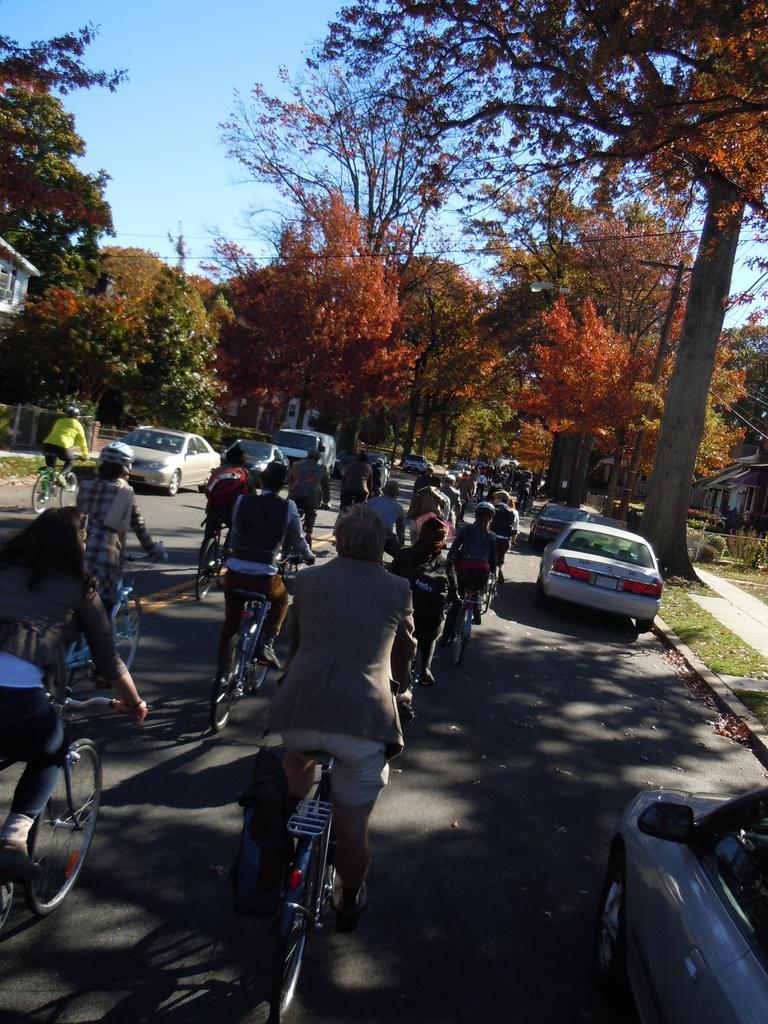Can you describe this image briefly? In this image there are people cycling on a road and there are vehicles, in the background there are trees and the sky. 